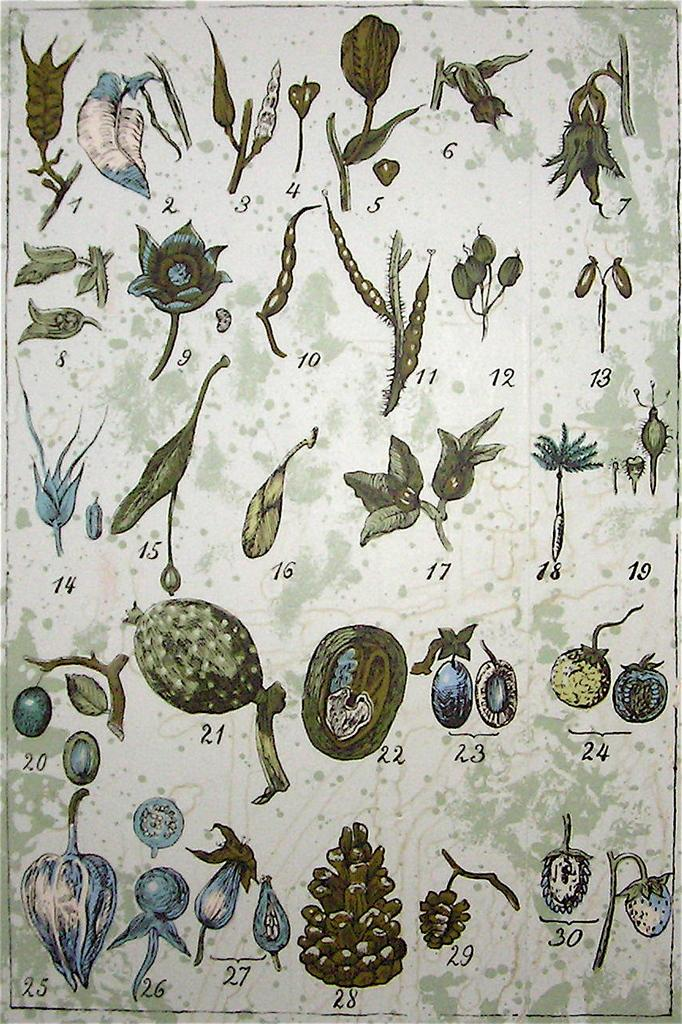What type of air theory can be observed in the image? There is no image provided, and therefore no air theory can be observed. What star is visible in the image? There is no image provided, and therefore no star can be observed. What type of air theory can be observed in the image? There is no image provided, and therefore no air theory can be observed. What star is visible in the image? There is no image provided, and therefore no star can be observed. Reasoning: Let's think step by step in order to create an absurd question based on the provided absurd topics. We start by acknowledging that there are no specific facts provided about the image. Then, we formulate an absurd question that incorporates one of the provided absurd topics, such as "air theory" or "star." Finally, we provide a polite and professional answer that explains why the absurd question cannot be answered based on the provided information. 